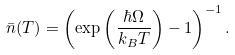Convert formula to latex. <formula><loc_0><loc_0><loc_500><loc_500>\bar { n } ( T ) = \left ( \exp \left ( \frac { \hbar { \Omega } } { k _ { B } T } \right ) - 1 \right ) ^ { - 1 } .</formula> 